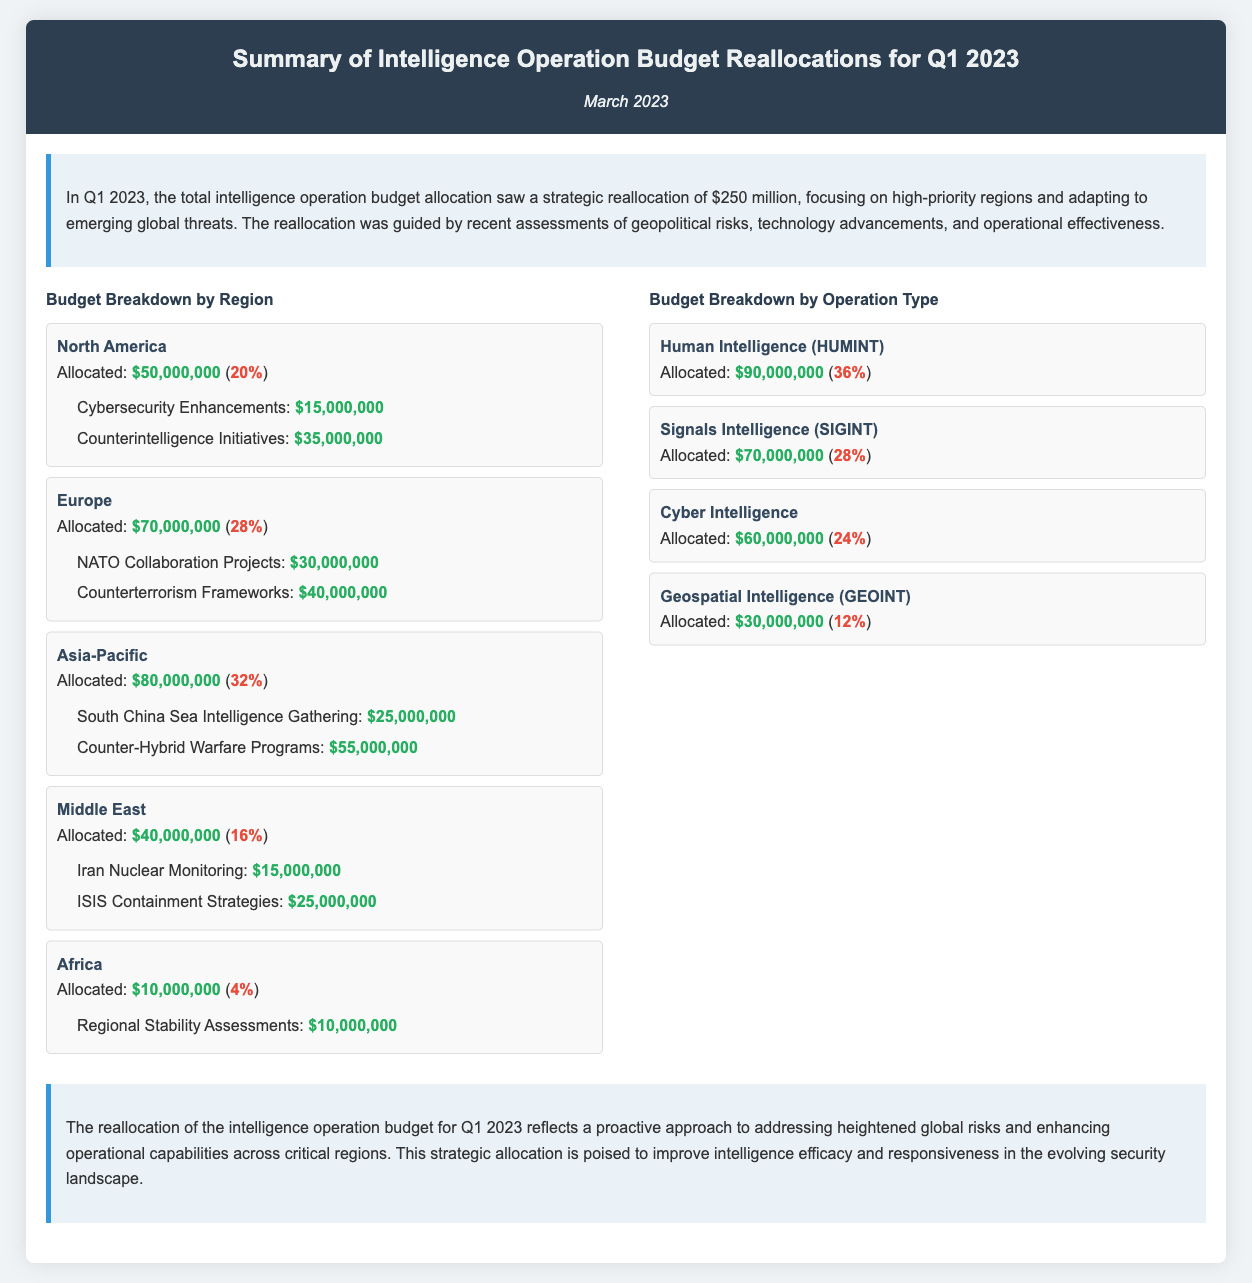What is the total intelligence operation budget reallocated in Q1 2023? The total intelligence operation budget allocation saw a strategic reallocation of $250 million as stated in the summary.
Answer: $250 million What percentage of the budget was allocated to the Asia-Pacific region? The Asia-Pacific region received $80 million which is stated as 32% of the total budget allocation.
Answer: 32% Which operation type received the highest allocation? The budget breakdown by operation type indicates that Human Intelligence (HUMINT) received $90 million, making it the highest.
Answer: Human Intelligence (HUMINT) How much was allocated for Counterterrorism Frameworks in Europe? The key operations under Europe details that $40 million was allocated for Counterterrorism Frameworks.
Answer: $40,000,000 Which region received the least allocation? The Africa region is noted to have received the least allocation of $10 million, as highlighted in the budget breakdown.
Answer: Africa What is the total allocation for Cyber Intelligence? Cyber Intelligence is detailed to have an allocation of $60 million, as mentioned in the budget breakdown by operation type.
Answer: $60,000,000 What was the function of the funding for South China Sea Intelligence Gathering? The specific function of the funding for South China Sea Intelligence Gathering is described under the Asia-Pacific region.
Answer: Intelligence Gathering How much of the budget was dedicated to Cybersecurity Enhancements in North America? The document states that Cybersecurity Enhancements received an allocation of $15 million under North America.
Answer: $15,000,000 What strategic approach does the reallocation reflect? The conclusion of the document states that the reallocation reflects a proactive approach to heightened global risks.
Answer: Proactive approach 